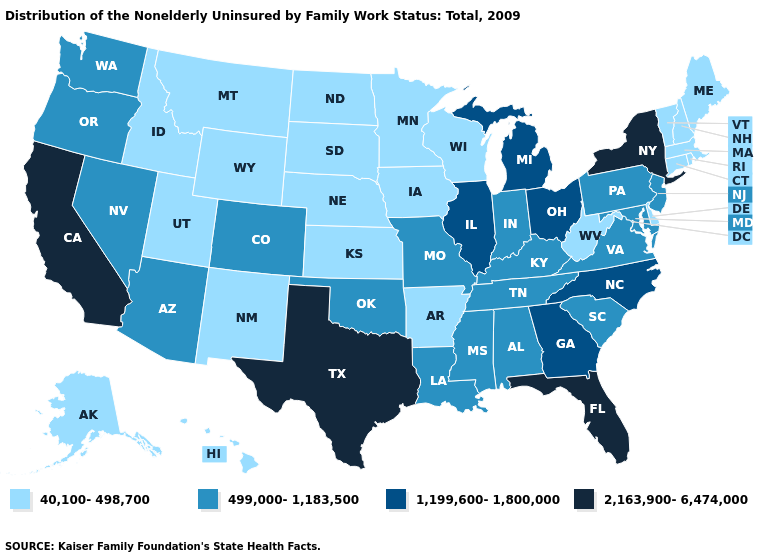Name the states that have a value in the range 40,100-498,700?
Write a very short answer. Alaska, Arkansas, Connecticut, Delaware, Hawaii, Idaho, Iowa, Kansas, Maine, Massachusetts, Minnesota, Montana, Nebraska, New Hampshire, New Mexico, North Dakota, Rhode Island, South Dakota, Utah, Vermont, West Virginia, Wisconsin, Wyoming. What is the value of Idaho?
Quick response, please. 40,100-498,700. Does California have the lowest value in the West?
Be succinct. No. Name the states that have a value in the range 2,163,900-6,474,000?
Concise answer only. California, Florida, New York, Texas. What is the value of Utah?
Be succinct. 40,100-498,700. Is the legend a continuous bar?
Answer briefly. No. What is the highest value in states that border Louisiana?
Short answer required. 2,163,900-6,474,000. What is the value of Kentucky?
Short answer required. 499,000-1,183,500. Which states have the lowest value in the West?
Give a very brief answer. Alaska, Hawaii, Idaho, Montana, New Mexico, Utah, Wyoming. Name the states that have a value in the range 40,100-498,700?
Give a very brief answer. Alaska, Arkansas, Connecticut, Delaware, Hawaii, Idaho, Iowa, Kansas, Maine, Massachusetts, Minnesota, Montana, Nebraska, New Hampshire, New Mexico, North Dakota, Rhode Island, South Dakota, Utah, Vermont, West Virginia, Wisconsin, Wyoming. Name the states that have a value in the range 1,199,600-1,800,000?
Quick response, please. Georgia, Illinois, Michigan, North Carolina, Ohio. Does Pennsylvania have the lowest value in the Northeast?
Be succinct. No. What is the lowest value in the Northeast?
Quick response, please. 40,100-498,700. Does Nevada have a lower value than South Carolina?
Quick response, please. No. What is the value of South Carolina?
Write a very short answer. 499,000-1,183,500. 